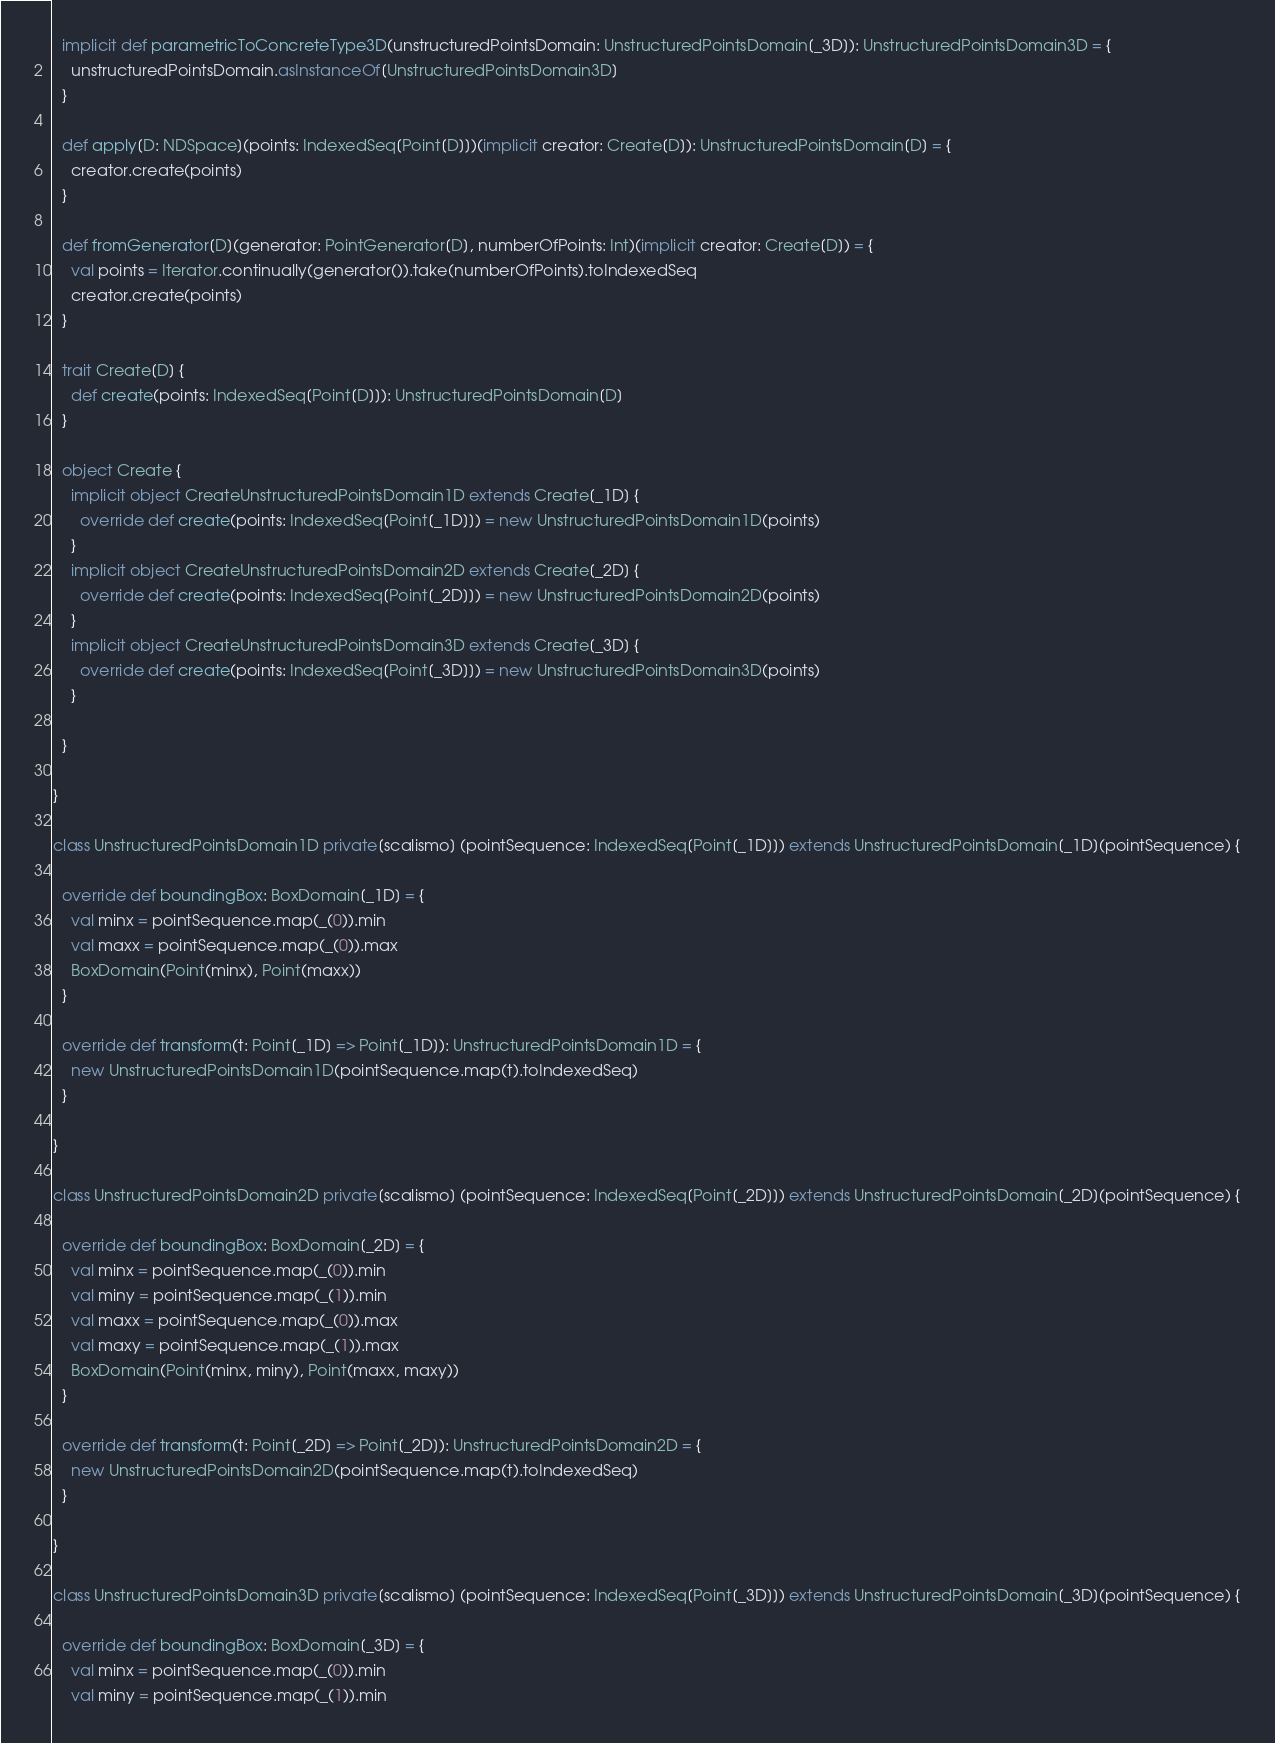Convert code to text. <code><loc_0><loc_0><loc_500><loc_500><_Scala_>  implicit def parametricToConcreteType3D(unstructuredPointsDomain: UnstructuredPointsDomain[_3D]): UnstructuredPointsDomain3D = {
    unstructuredPointsDomain.asInstanceOf[UnstructuredPointsDomain3D]
  }

  def apply[D: NDSpace](points: IndexedSeq[Point[D]])(implicit creator: Create[D]): UnstructuredPointsDomain[D] = {
    creator.create(points)
  }

  def fromGenerator[D](generator: PointGenerator[D], numberOfPoints: Int)(implicit creator: Create[D]) = {
    val points = Iterator.continually(generator()).take(numberOfPoints).toIndexedSeq
    creator.create(points)
  }

  trait Create[D] {
    def create(points: IndexedSeq[Point[D]]): UnstructuredPointsDomain[D]
  }

  object Create {
    implicit object CreateUnstructuredPointsDomain1D extends Create[_1D] {
      override def create(points: IndexedSeq[Point[_1D]]) = new UnstructuredPointsDomain1D(points)
    }
    implicit object CreateUnstructuredPointsDomain2D extends Create[_2D] {
      override def create(points: IndexedSeq[Point[_2D]]) = new UnstructuredPointsDomain2D(points)
    }
    implicit object CreateUnstructuredPointsDomain3D extends Create[_3D] {
      override def create(points: IndexedSeq[Point[_3D]]) = new UnstructuredPointsDomain3D(points)
    }

  }

}

class UnstructuredPointsDomain1D private[scalismo] (pointSequence: IndexedSeq[Point[_1D]]) extends UnstructuredPointsDomain[_1D](pointSequence) {

  override def boundingBox: BoxDomain[_1D] = {
    val minx = pointSequence.map(_(0)).min
    val maxx = pointSequence.map(_(0)).max
    BoxDomain(Point(minx), Point(maxx))
  }

  override def transform(t: Point[_1D] => Point[_1D]): UnstructuredPointsDomain1D = {
    new UnstructuredPointsDomain1D(pointSequence.map(t).toIndexedSeq)
  }

}

class UnstructuredPointsDomain2D private[scalismo] (pointSequence: IndexedSeq[Point[_2D]]) extends UnstructuredPointsDomain[_2D](pointSequence) {

  override def boundingBox: BoxDomain[_2D] = {
    val minx = pointSequence.map(_(0)).min
    val miny = pointSequence.map(_(1)).min
    val maxx = pointSequence.map(_(0)).max
    val maxy = pointSequence.map(_(1)).max
    BoxDomain(Point(minx, miny), Point(maxx, maxy))
  }

  override def transform(t: Point[_2D] => Point[_2D]): UnstructuredPointsDomain2D = {
    new UnstructuredPointsDomain2D(pointSequence.map(t).toIndexedSeq)
  }

}

class UnstructuredPointsDomain3D private[scalismo] (pointSequence: IndexedSeq[Point[_3D]]) extends UnstructuredPointsDomain[_3D](pointSequence) {

  override def boundingBox: BoxDomain[_3D] = {
    val minx = pointSequence.map(_(0)).min
    val miny = pointSequence.map(_(1)).min</code> 